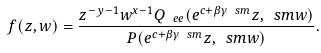<formula> <loc_0><loc_0><loc_500><loc_500>f ( z , w ) = \frac { z ^ { - y - 1 } w ^ { x - 1 } Q _ { \ e { e } } ( e ^ { c + \beta \gamma \ s m } z , \ s m w ) } { P ( e ^ { c + \beta \gamma \ s m } z , \ s m w ) } .</formula> 